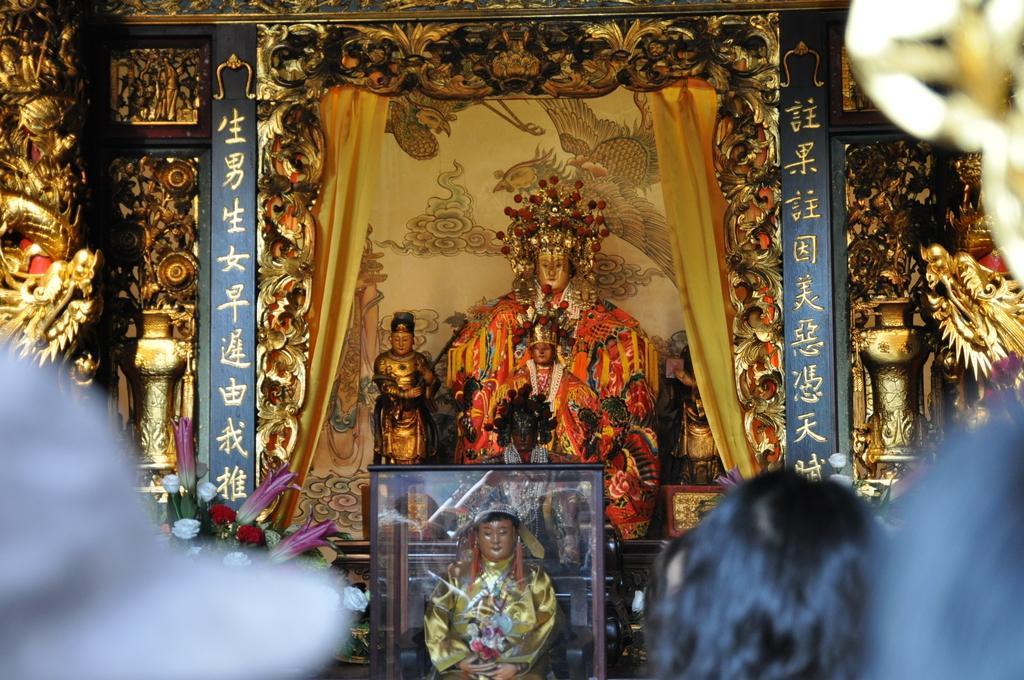Describe this image in one or two sentences. In this image, we can see some people and in the background, there are statues, sculptures, flowers and we can see a frame. 